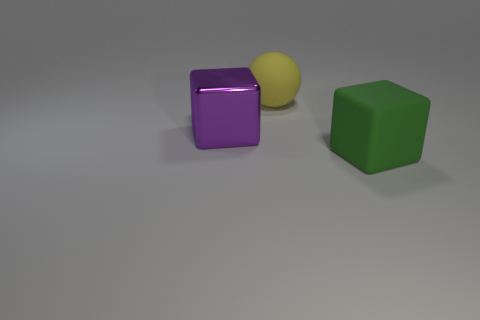Add 3 balls. How many objects exist? 6 Subtract all balls. How many objects are left? 2 Add 1 large purple shiny things. How many large purple shiny things are left? 2 Add 3 shiny objects. How many shiny objects exist? 4 Subtract 1 green blocks. How many objects are left? 2 Subtract all small cylinders. Subtract all large balls. How many objects are left? 2 